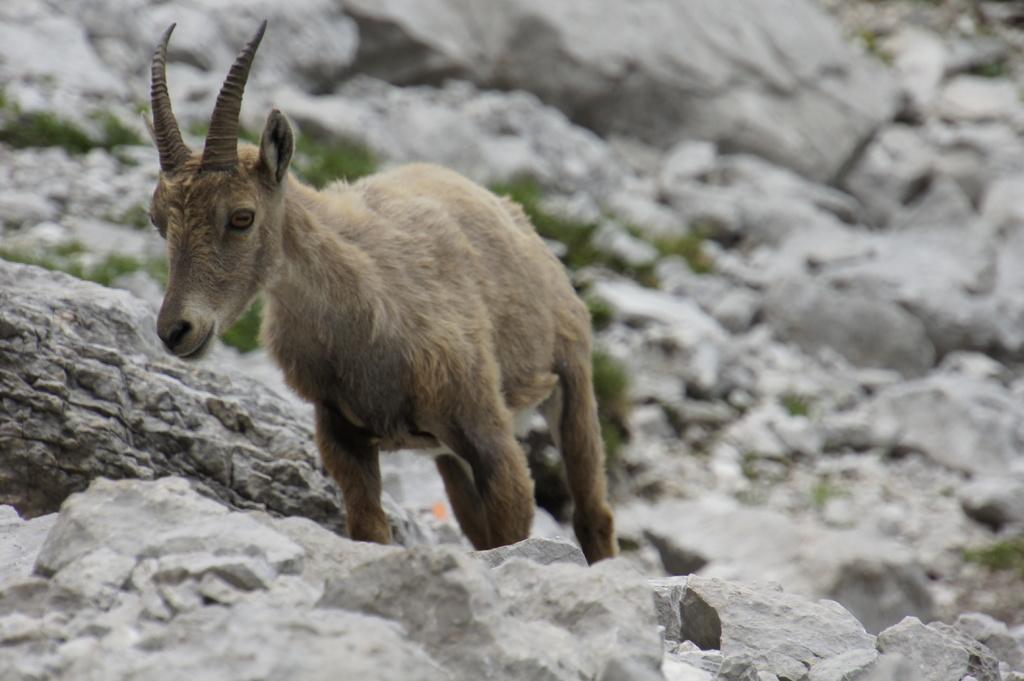In one or two sentences, can you explain what this image depicts? In the center of the image, we can see an animal and in the background, there are rocks and we can see grass. 